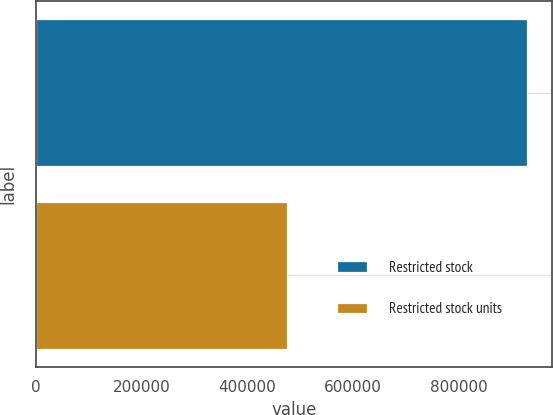Convert chart. <chart><loc_0><loc_0><loc_500><loc_500><bar_chart><fcel>Restricted stock<fcel>Restricted stock units<nl><fcel>929990<fcel>475000<nl></chart> 